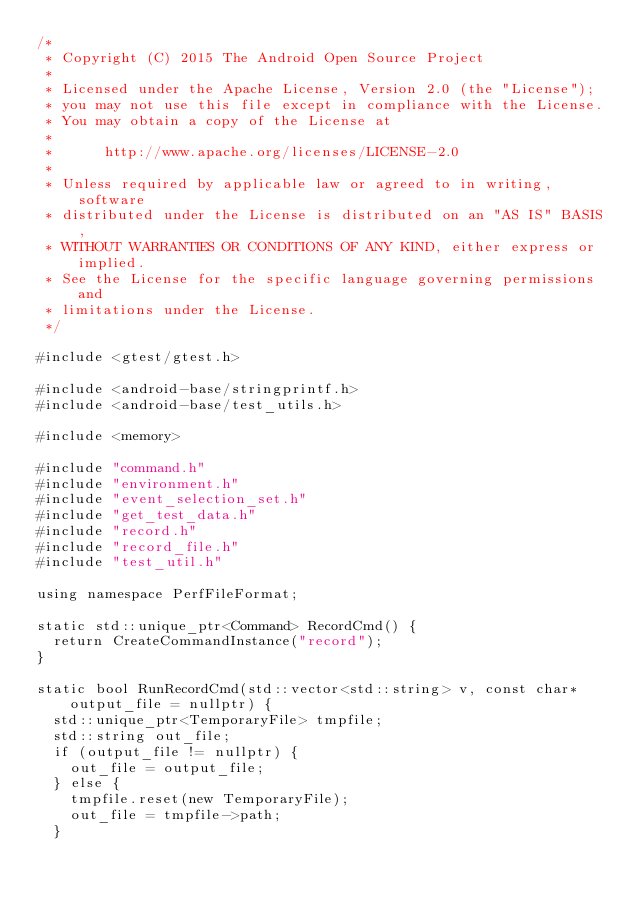<code> <loc_0><loc_0><loc_500><loc_500><_C++_>/*
 * Copyright (C) 2015 The Android Open Source Project
 *
 * Licensed under the Apache License, Version 2.0 (the "License");
 * you may not use this file except in compliance with the License.
 * You may obtain a copy of the License at
 *
 *      http://www.apache.org/licenses/LICENSE-2.0
 *
 * Unless required by applicable law or agreed to in writing, software
 * distributed under the License is distributed on an "AS IS" BASIS,
 * WITHOUT WARRANTIES OR CONDITIONS OF ANY KIND, either express or implied.
 * See the License for the specific language governing permissions and
 * limitations under the License.
 */

#include <gtest/gtest.h>

#include <android-base/stringprintf.h>
#include <android-base/test_utils.h>

#include <memory>

#include "command.h"
#include "environment.h"
#include "event_selection_set.h"
#include "get_test_data.h"
#include "record.h"
#include "record_file.h"
#include "test_util.h"

using namespace PerfFileFormat;

static std::unique_ptr<Command> RecordCmd() {
  return CreateCommandInstance("record");
}

static bool RunRecordCmd(std::vector<std::string> v, const char* output_file = nullptr) {
  std::unique_ptr<TemporaryFile> tmpfile;
  std::string out_file;
  if (output_file != nullptr) {
    out_file = output_file;
  } else {
    tmpfile.reset(new TemporaryFile);
    out_file = tmpfile->path;
  }</code> 